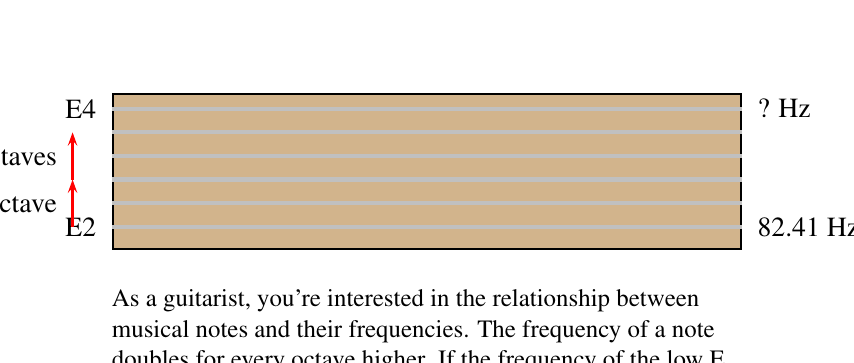Can you solve this math problem? Let's approach this step-by-step:

1) We know that the frequency doubles for each octave higher. We can express this mathematically as:

   $$f_n = f_0 \cdot 2^n$$

   Where $f_n$ is the frequency of the note $n$ octaves higher than the starting note with frequency $f_0$.

2) In this case:
   - $f_0 = 82.41$ Hz (the frequency of E2)
   - $n = 2$ (we're going up two octaves from E2 to E4)

3) Let's plug these values into our equation:

   $$f_2 = 82.41 \cdot 2^2$$

4) Simplify the exponent:
   
   $$f_2 = 82.41 \cdot 4$$

5) Calculate:
   
   $$f_2 = 329.64\text{ Hz}$$

6) Rounding to the nearest whole number:

   $$f_2 \approx 330\text{ Hz}$$

Therefore, the frequency of the high E string (E4) is approximately 330 Hz.
Answer: 330 Hz 